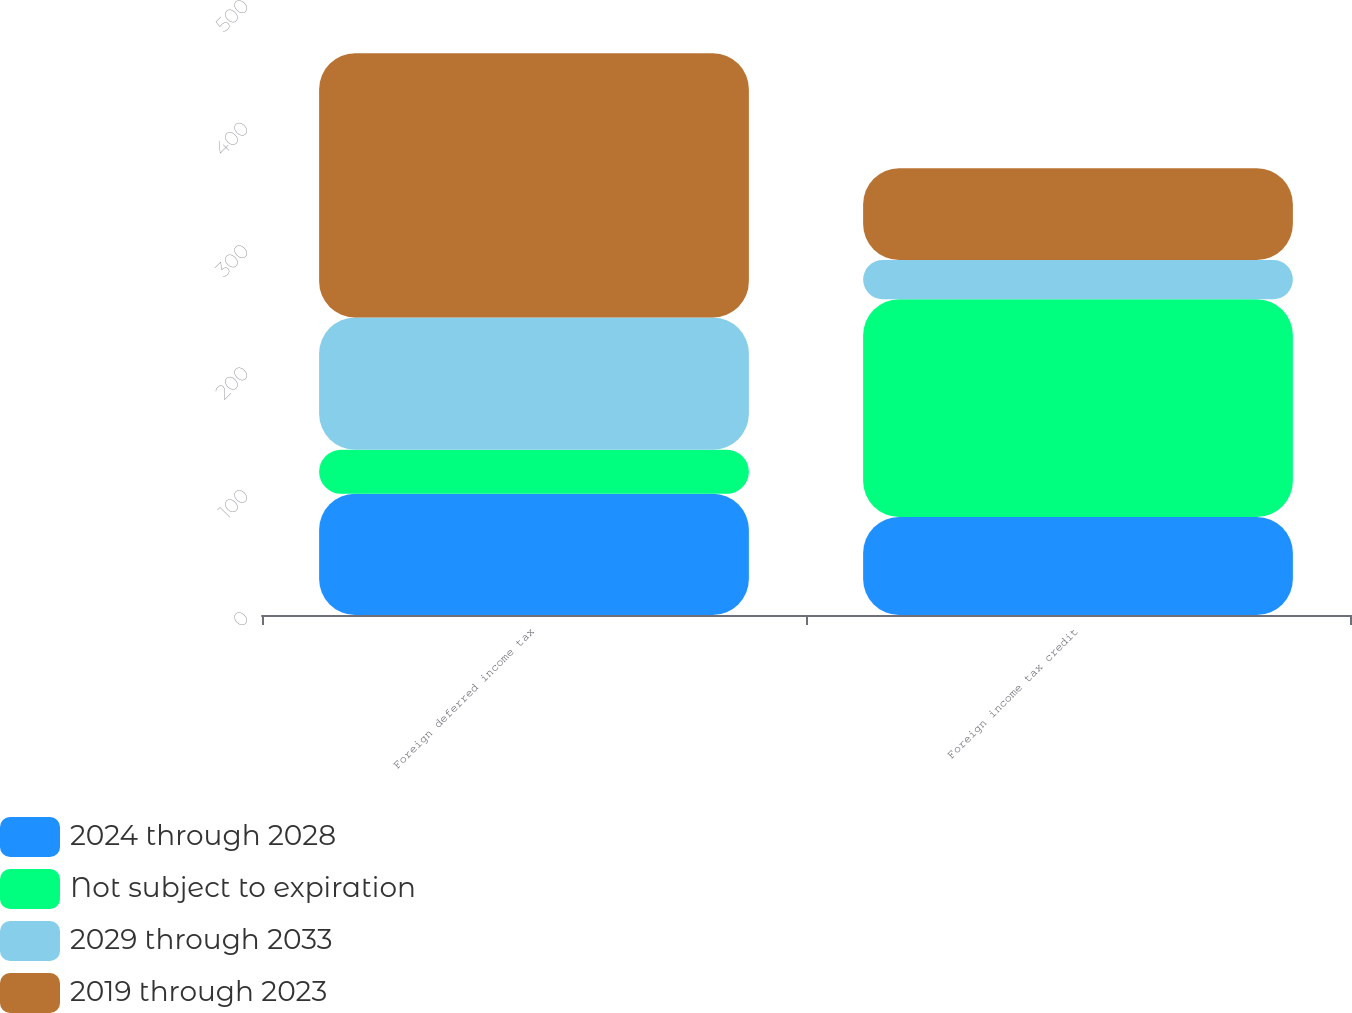<chart> <loc_0><loc_0><loc_500><loc_500><stacked_bar_chart><ecel><fcel>Foreign deferred income tax<fcel>Foreign income tax credit<nl><fcel>2024 through 2028<fcel>99<fcel>80<nl><fcel>Not subject to expiration<fcel>36<fcel>178<nl><fcel>2029 through 2033<fcel>108<fcel>32<nl><fcel>2019 through 2023<fcel>216<fcel>75<nl></chart> 